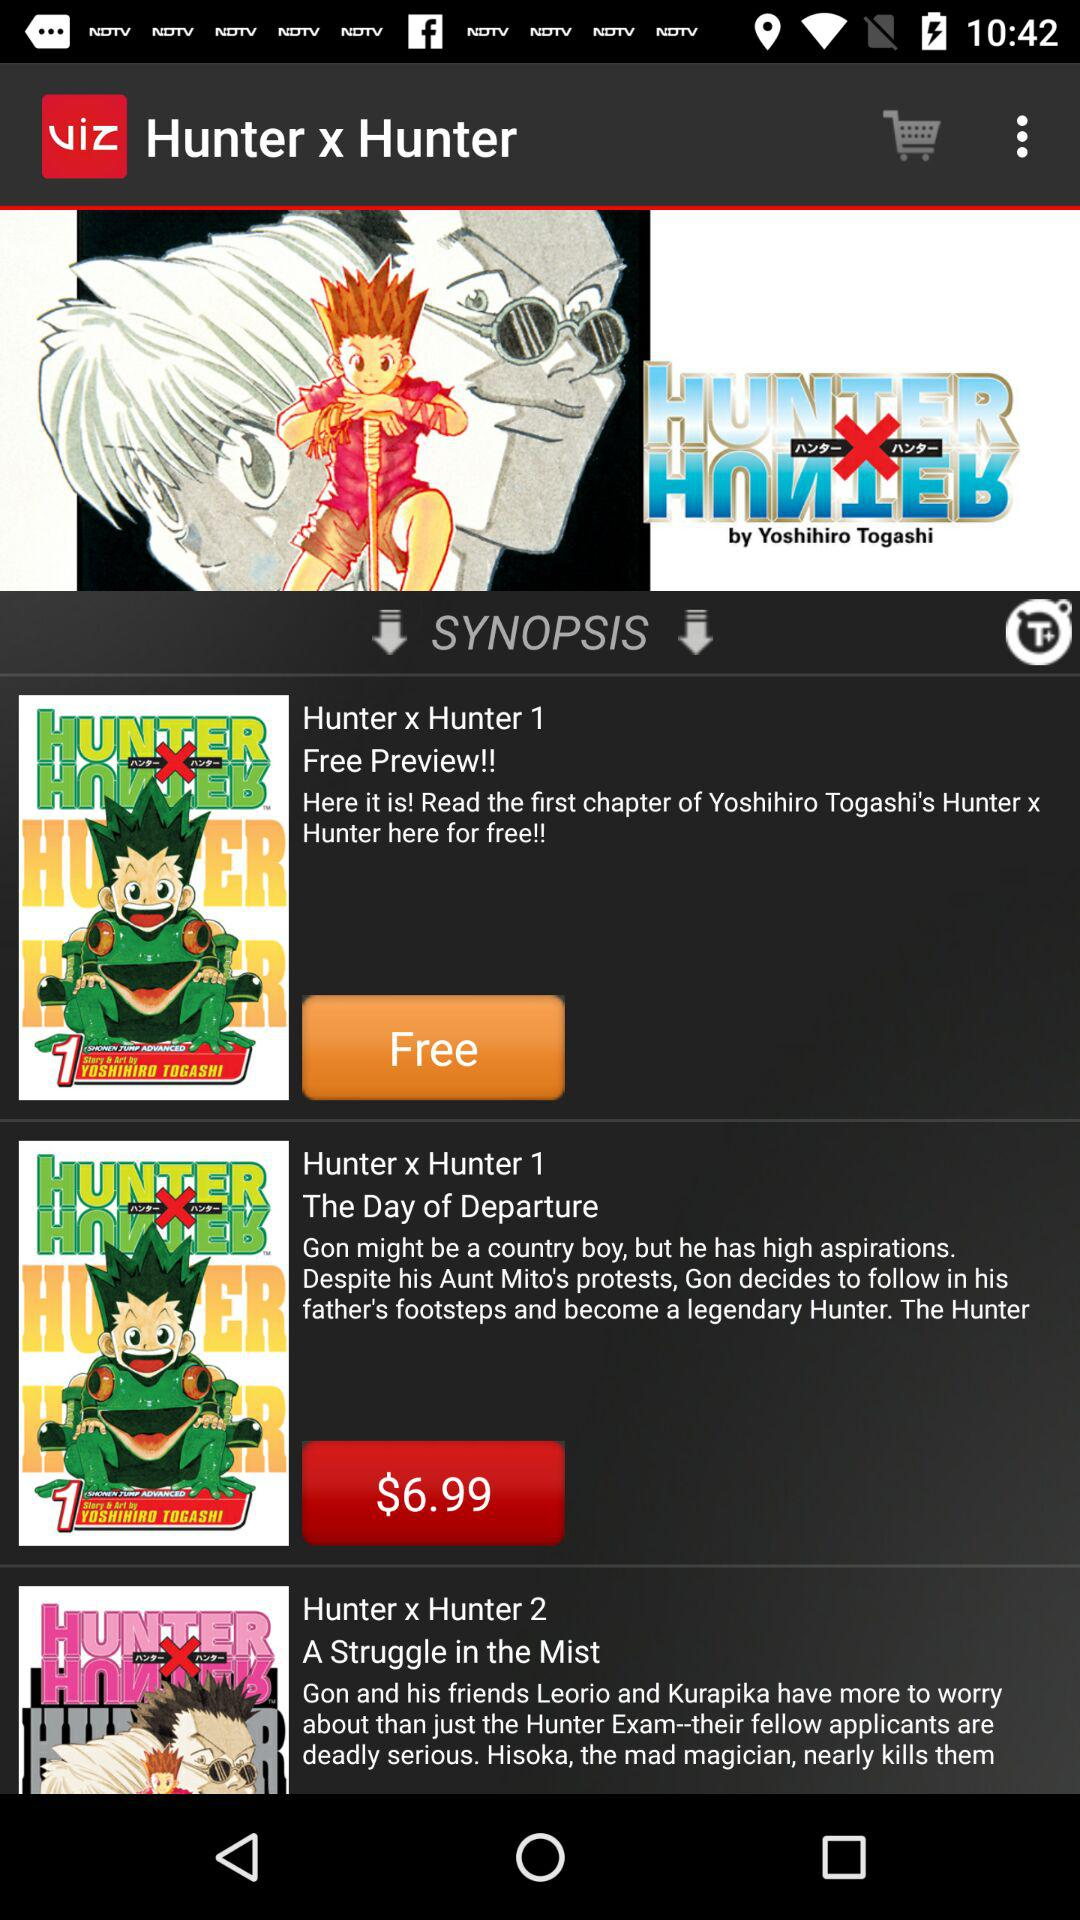What is the price for the free preview? The price is "Free". 